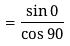<formula> <loc_0><loc_0><loc_500><loc_500>= \frac { \sin 0 } { \cos 9 0 }</formula> 